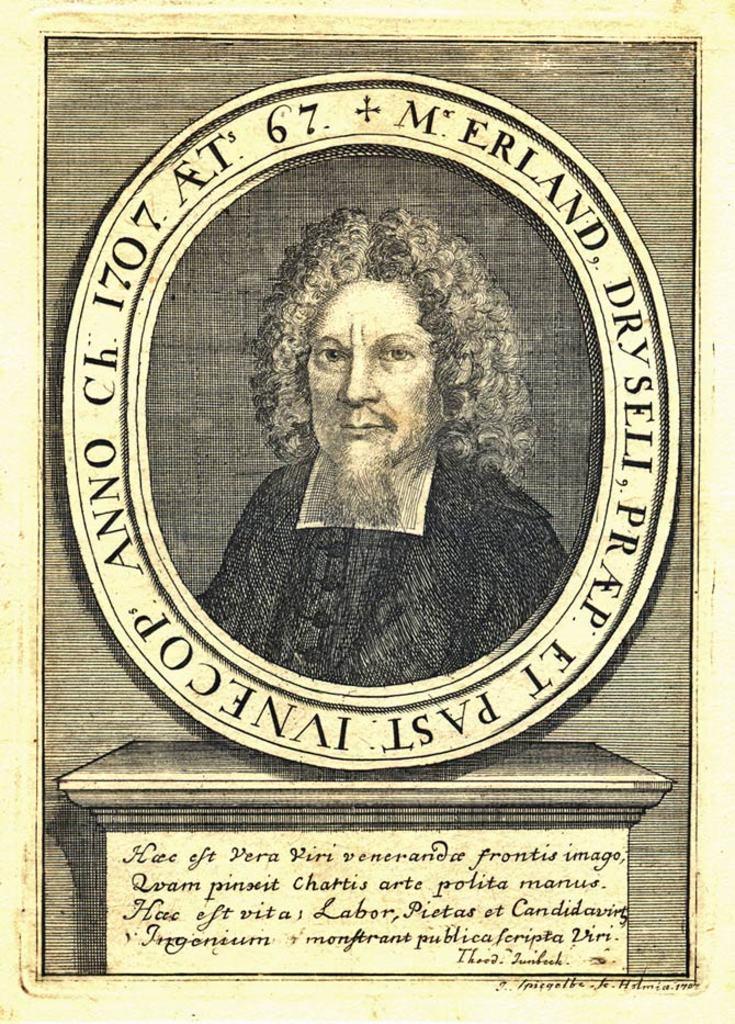Please provide a concise description of this image. Here we can see a paper, in this paper we can see a memorial of a person and some text. 